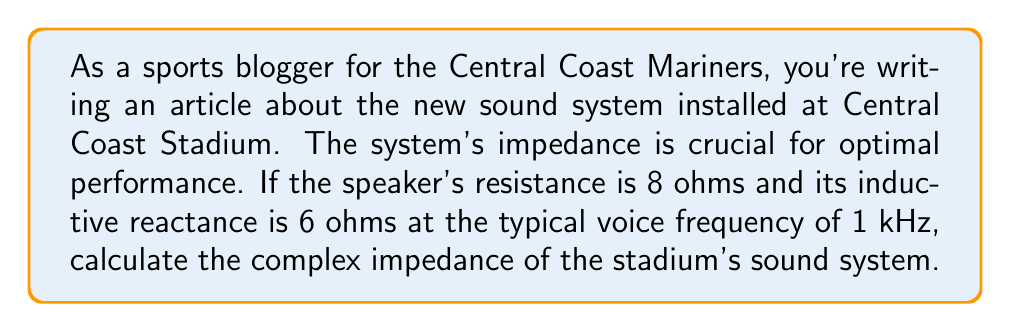Solve this math problem. To solve this problem, we need to use the concept of complex impedance in electrical circuits. The complex impedance Z is composed of a real part (resistance R) and an imaginary part (reactance X).

1. Given:
   - Resistance (R) = 8 ohms
   - Inductive reactance (X_L) = 6 ohms

2. The complex impedance is represented as:
   $$ Z = R + jX_L $$
   where j is the imaginary unit (√-1).

3. Substituting the values:
   $$ Z = 8 + j6 $$

4. This can be written in polar form as:
   $$ Z = |Z| \angle \theta $$

5. To find the magnitude |Z|:
   $$ |Z| = \sqrt{R^2 + X_L^2} = \sqrt{8^2 + 6^2} = \sqrt{64 + 36} = \sqrt{100} = 10 \text{ ohms} $$

6. To find the phase angle θ:
   $$ \theta = \tan^{-1}\left(\frac{X_L}{R}\right) = \tan^{-1}\left(\frac{6}{8}\right) \approx 36.87° $$

7. Therefore, the complex impedance in polar form is:
   $$ Z = 10 \angle 36.87° \text{ ohms} $$

This impedance value is crucial for matching the amplifier output to the speaker system, ensuring optimal power transfer and sound quality in the stadium.
Answer: $$ Z = 8 + j6 \text{ ohms} \text{ or } Z = 10 \angle 36.87° \text{ ohms} $$ 